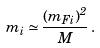<formula> <loc_0><loc_0><loc_500><loc_500>m _ { i } \simeq \frac { ( m _ { F i } ) ^ { 2 } } { M } \, .</formula> 